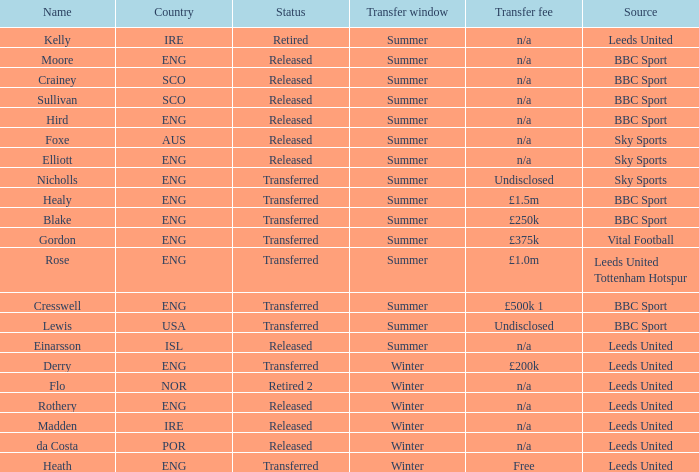What was the source of an ENG transfer that paid a £1.5m transfer fee? BBC Sport. 